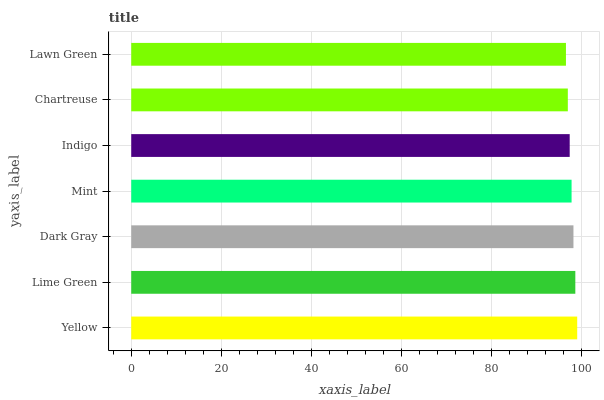Is Lawn Green the minimum?
Answer yes or no. Yes. Is Yellow the maximum?
Answer yes or no. Yes. Is Lime Green the minimum?
Answer yes or no. No. Is Lime Green the maximum?
Answer yes or no. No. Is Yellow greater than Lime Green?
Answer yes or no. Yes. Is Lime Green less than Yellow?
Answer yes or no. Yes. Is Lime Green greater than Yellow?
Answer yes or no. No. Is Yellow less than Lime Green?
Answer yes or no. No. Is Mint the high median?
Answer yes or no. Yes. Is Mint the low median?
Answer yes or no. Yes. Is Lime Green the high median?
Answer yes or no. No. Is Lime Green the low median?
Answer yes or no. No. 